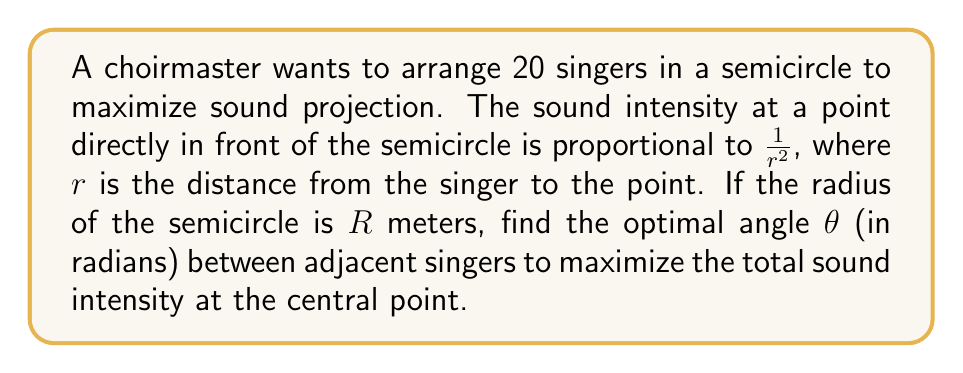Could you help me with this problem? 1) Let's consider a single singer positioned at angle $\alpha$ from the center of the semicircle. The distance $r$ from this singer to the central point is:

   $r = \sqrt{R^2 + R^2 - 2R^2\cos\alpha} = R\sqrt{2(1-\cos\alpha)}$

2) The sound intensity from this singer is proportional to:

   $I(\alpha) \propto \frac{1}{r^2} = \frac{1}{2R^2(1-\cos\alpha)}$

3) For 20 singers, the angle between adjacent singers is $\theta = \frac{\pi}{19}$. The total sound intensity is proportional to the sum:

   $I_{total} \propto \sum_{k=0}^{19} \frac{1}{2R^2(1-\cos(k\theta))}$

4) To maximize this, we need to find $\frac{dI_{total}}{d\theta} = 0$. This leads to a complex equation that's difficult to solve analytically.

5) However, we can use the fact that for small angles, $\cos\alpha \approx 1 - \frac{\alpha^2}{2}$. This approximation is valid here as $\theta$ is small.

6) Using this approximation:

   $I_{total} \propto \sum_{k=0}^{19} \frac{1}{R^2k^2\theta^2} = \frac{1}{R^2\theta^2}\sum_{k=1}^{19} \frac{1}{k^2}$

7) The sum $\sum_{k=1}^{19} \frac{1}{k^2}$ is a constant. Let's call it $C$. Then:

   $I_{total} \propto \frac{C}{R^2\theta^2}$

8) To maximize this, we need to minimize $\theta$, which means making it as small as possible while still fitting all singers in the semicircle.

9) The smallest possible $\theta$ that fits 20 singers in a semicircle is:

   $\theta = \frac{\pi}{19}$ radians
Answer: $\frac{\pi}{19}$ radians 